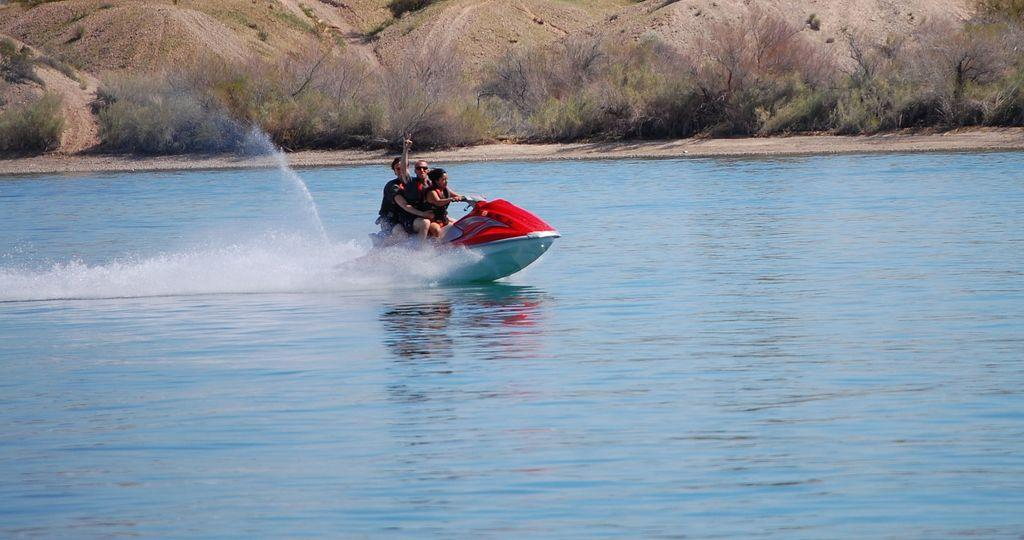How many people are in the image? There are three people in the image. What are the people doing in the image? The people are sitting in a speed boat. What type of environment is visible in the image? There is water and grass visible in the image. What color is the nose of the sail in the image? There is no sail or nose present in the image. How many beads are on the grass in the image? There are no beads visible in the image; only water and grass can be seen. 